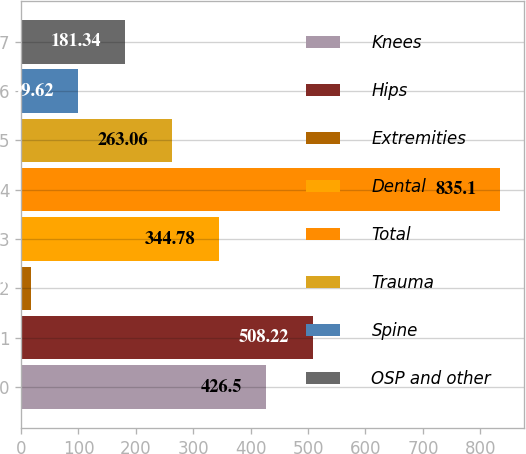Convert chart. <chart><loc_0><loc_0><loc_500><loc_500><bar_chart><fcel>Knees<fcel>Hips<fcel>Extremities<fcel>Dental<fcel>Total<fcel>Trauma<fcel>Spine<fcel>OSP and other<nl><fcel>426.5<fcel>508.22<fcel>17.9<fcel>344.78<fcel>835.1<fcel>263.06<fcel>99.62<fcel>181.34<nl></chart> 